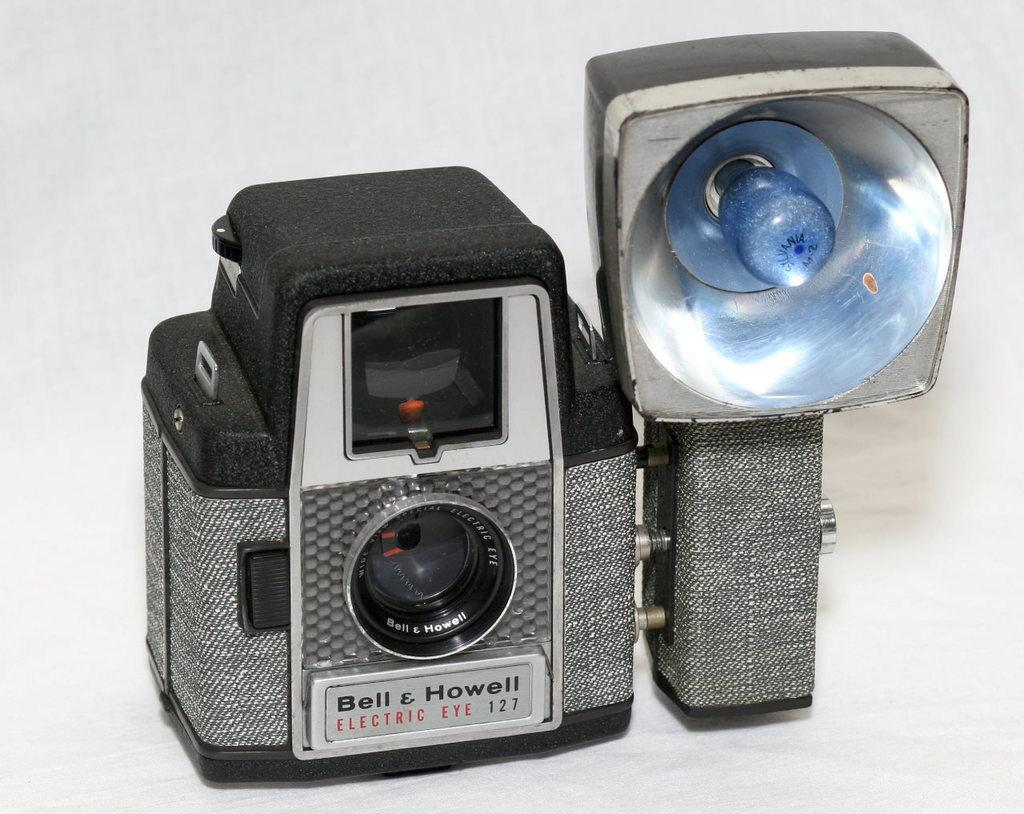What object is the main subject of the image? There is a camera in the image. On what surface is the camera placed? The camera is placed on a white surface. What color is the background of the image? The background of the image is white. What type of lace is used to decorate the camera in the image? There is no lace present on the camera in the image. Can you tell me how the spark from the camera affects the white background? There is no spark present in the image, and therefore it cannot affect the white background. 